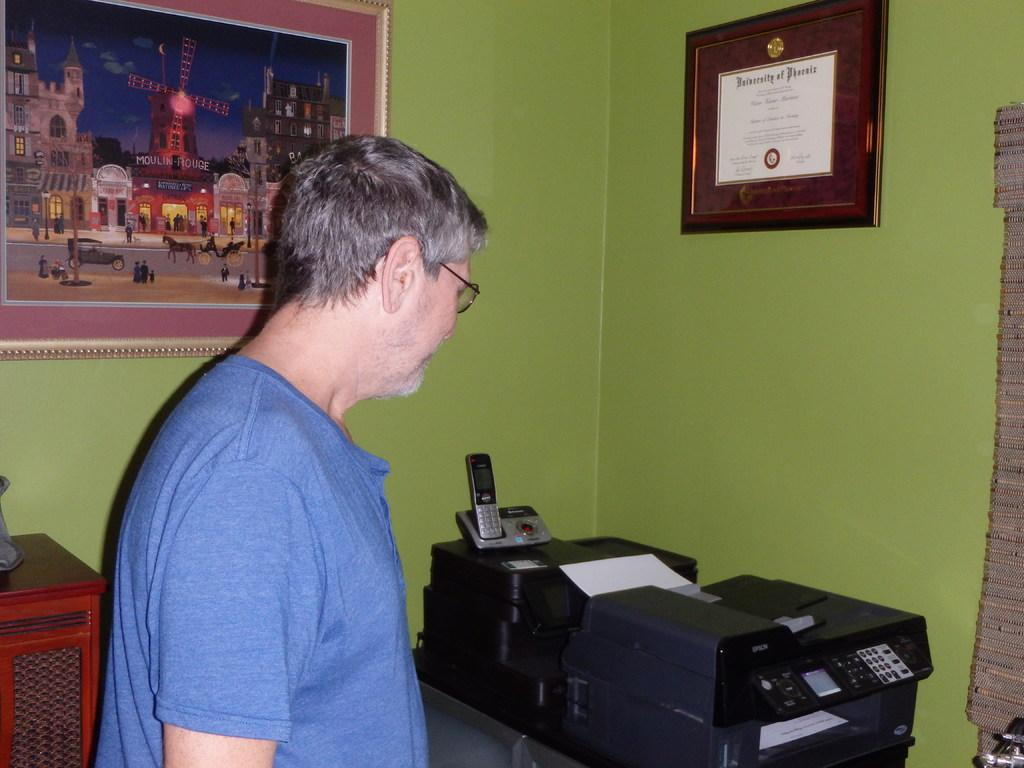<image>
Summarize the visual content of the image. A man stands in front of an Epson printer and their is a degree from the University of Phoenix framed on the wall. 